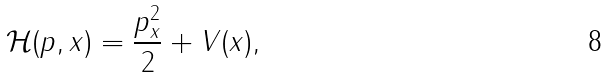<formula> <loc_0><loc_0><loc_500><loc_500>\mathcal { H } ( p , x ) = \frac { p _ { x } ^ { 2 } } { 2 } + V ( x ) ,</formula> 